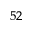<formula> <loc_0><loc_0><loc_500><loc_500>^ { 5 2 }</formula> 